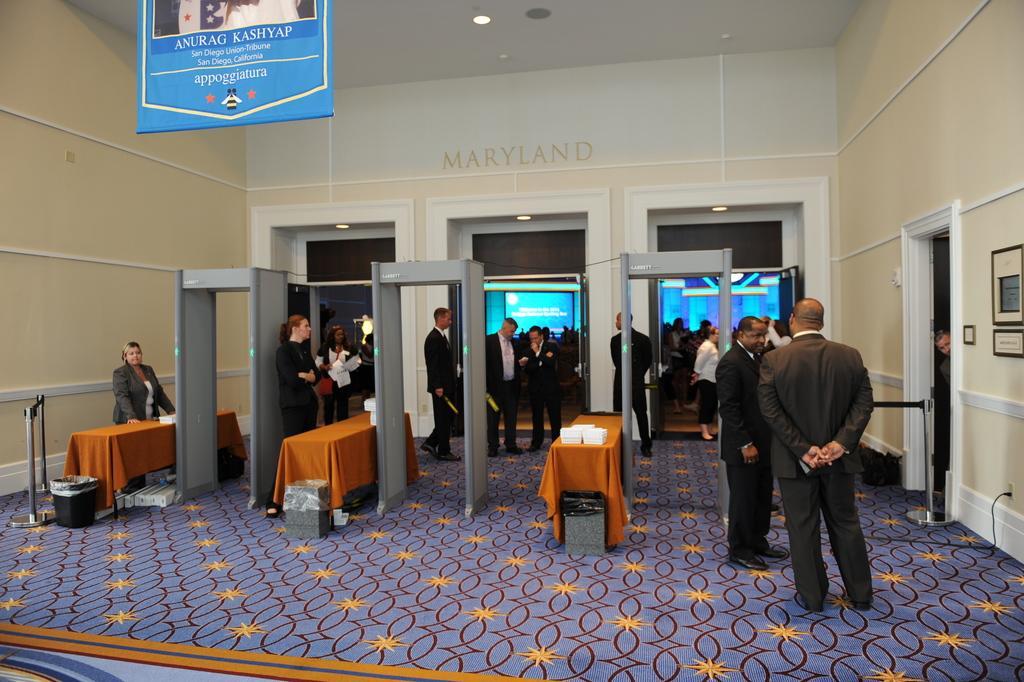In one or two sentences, can you explain what this image depicts? In the image there is a building and at the entrance of the building there many security officers, tables and scanning machines. Inside the building there are a lot of people and some screens in front of those people. 